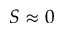<formula> <loc_0><loc_0><loc_500><loc_500>S \approx 0</formula> 